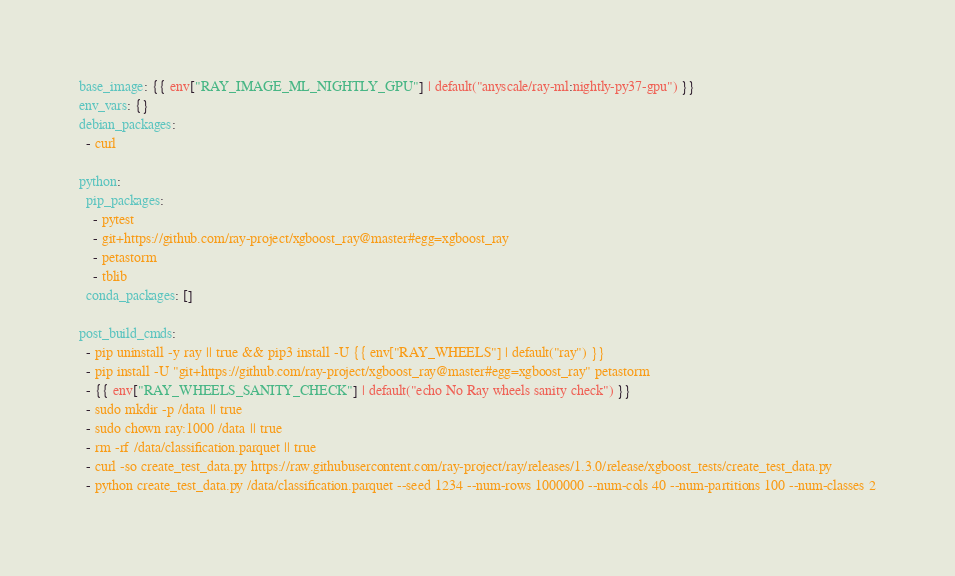Convert code to text. <code><loc_0><loc_0><loc_500><loc_500><_YAML_>base_image: {{ env["RAY_IMAGE_ML_NIGHTLY_GPU"] | default("anyscale/ray-ml:nightly-py37-gpu") }}
env_vars: {}
debian_packages:
  - curl

python:
  pip_packages:
    - pytest
    - git+https://github.com/ray-project/xgboost_ray@master#egg=xgboost_ray
    - petastorm
    - tblib
  conda_packages: []

post_build_cmds:
  - pip uninstall -y ray || true && pip3 install -U {{ env["RAY_WHEELS"] | default("ray") }}
  - pip install -U "git+https://github.com/ray-project/xgboost_ray@master#egg=xgboost_ray" petastorm
  - {{ env["RAY_WHEELS_SANITY_CHECK"] | default("echo No Ray wheels sanity check") }}
  - sudo mkdir -p /data || true
  - sudo chown ray:1000 /data || true
  - rm -rf /data/classification.parquet || true
  - curl -so create_test_data.py https://raw.githubusercontent.com/ray-project/ray/releases/1.3.0/release/xgboost_tests/create_test_data.py
  - python create_test_data.py /data/classification.parquet --seed 1234 --num-rows 1000000 --num-cols 40 --num-partitions 100 --num-classes 2
</code> 